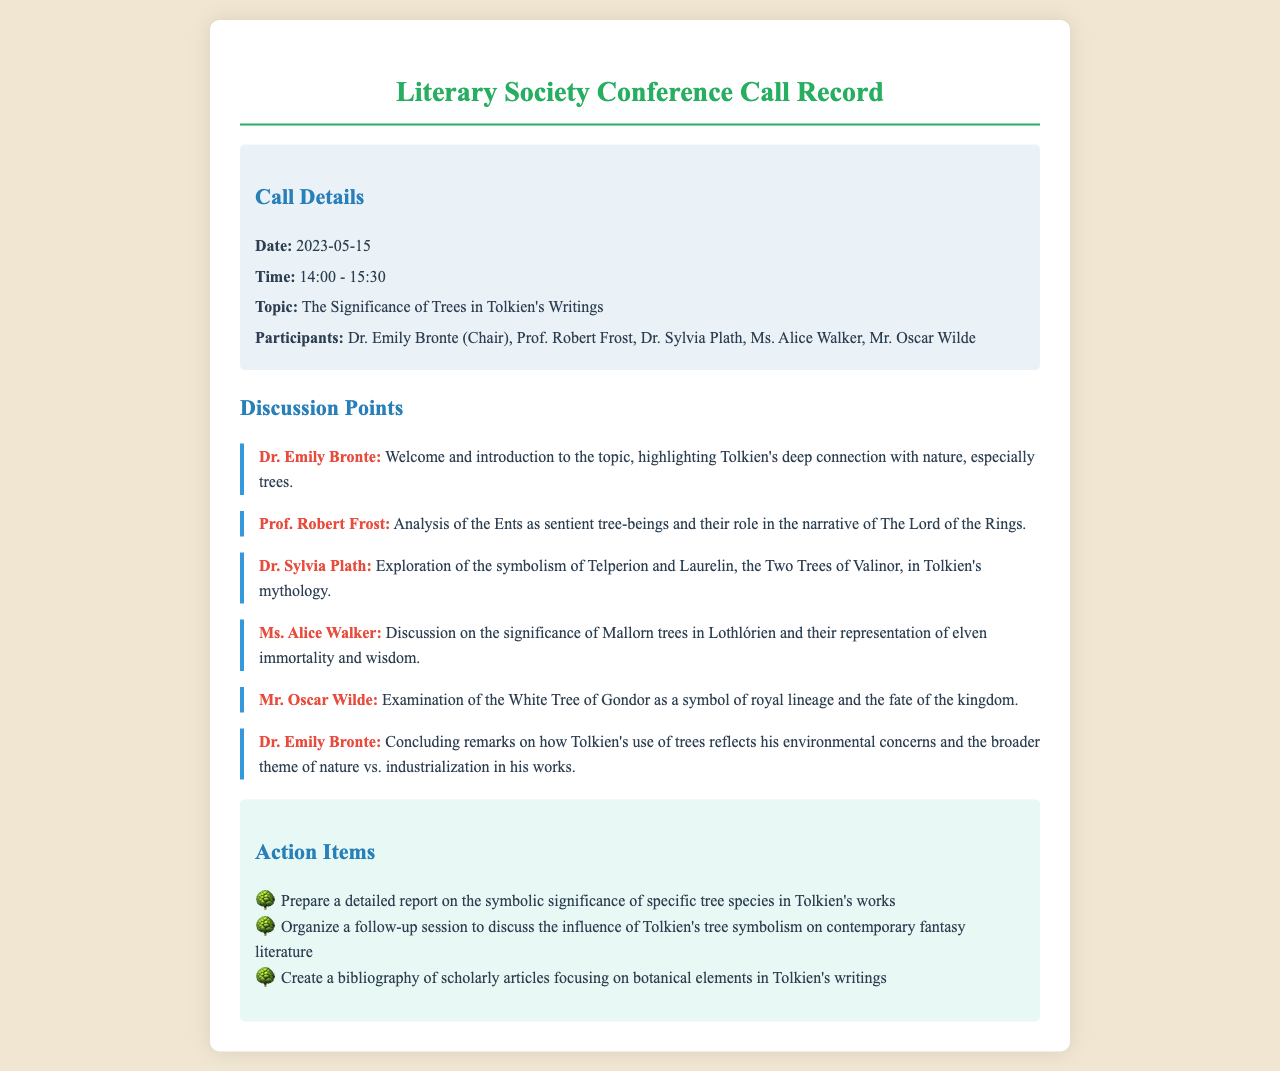What was the date of the conference call? The date is explicitly stated in the call details section of the document.
Answer: 2023-05-15 Who chaired the conference call? The chairperson of the conference call is mentioned in the participants section.
Answer: Dr. Emily Bronte What was the main topic of discussion? The topic is provided in the call details section and summarizes the central theme of the meeting.
Answer: The Significance of Trees in Tolkien's Writings Which tree represents elven immortality? The discussion on trees includes specific symbolism associated with elven themes, mentioned by a participant.
Answer: Mallorn trees What is one of the action items discussed? Action items are presented as a list towards the end of the document, indicating tasks for future activities.
Answer: Prepare a detailed report on the symbolic significance of specific tree species in Tolkien's works Who discussed the Ents during the call? The speaker is identified in the discussion points where the analysis of Ents is mentioned.
Answer: Prof. Robert Frost What time did the call start? The time is stated in the call details, showing when the discussion commenced.
Answer: 14:00 What symbolism is associated with the White Tree of Gondor? The discussion points highlight specific symbols attributed to various trees within Tolkien's writings.
Answer: royal lineage and the fate of the kingdom 